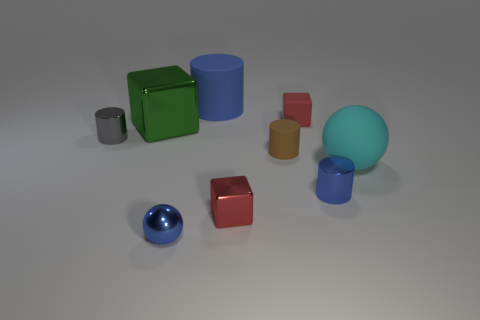There is a large rubber object in front of the big rubber thing behind the green metallic object; what color is it?
Keep it short and to the point. Cyan. What number of things are either metallic things that are behind the blue metal sphere or yellow shiny things?
Keep it short and to the point. 4. Does the gray cylinder have the same size as the cube that is on the left side of the blue rubber cylinder?
Ensure brevity in your answer.  No. How many small things are matte cylinders or blue spheres?
Your response must be concise. 2. What is the shape of the big cyan matte object?
Provide a short and direct response. Sphere. There is a metallic cylinder that is the same color as the tiny shiny ball; what is its size?
Your answer should be compact. Small. Is there a tiny cube that has the same material as the big cyan sphere?
Your answer should be compact. Yes. Are there more large green rubber cylinders than tiny metallic balls?
Offer a terse response. No. Are the small blue cylinder and the large cylinder made of the same material?
Ensure brevity in your answer.  No. How many metallic things are either green objects or small gray cylinders?
Ensure brevity in your answer.  2. 